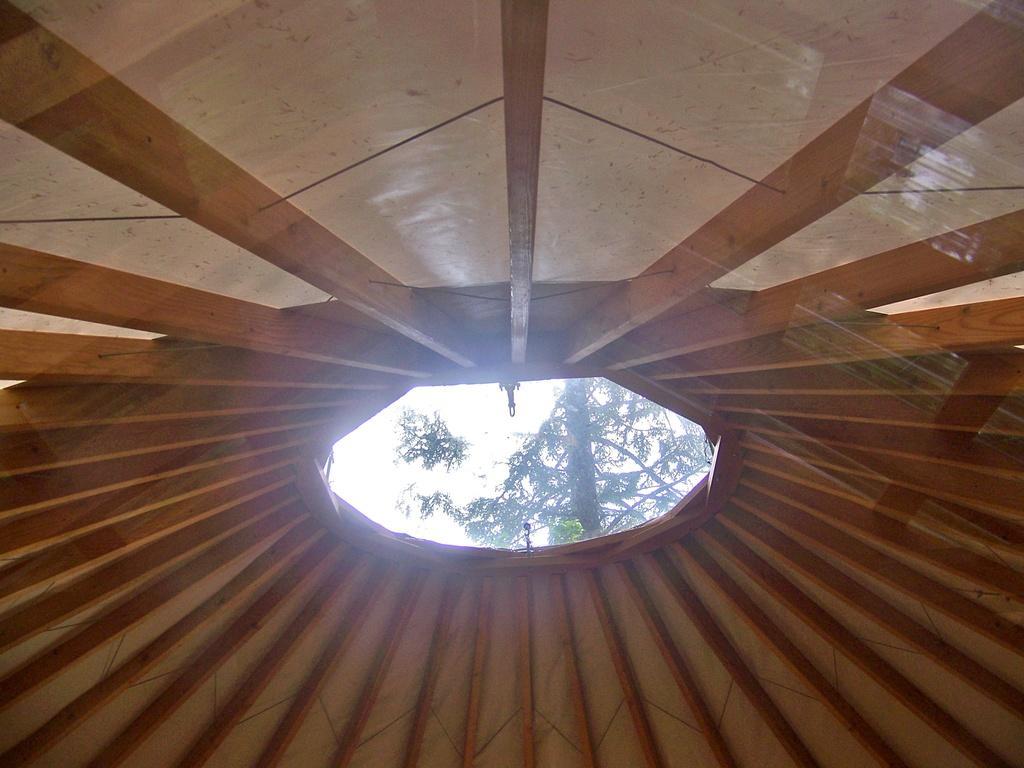Can you describe this image briefly? This picture looks like a tent and I can see a tree. 